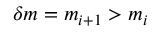Convert formula to latex. <formula><loc_0><loc_0><loc_500><loc_500>\delta m = m _ { i + 1 } > m _ { i }</formula> 